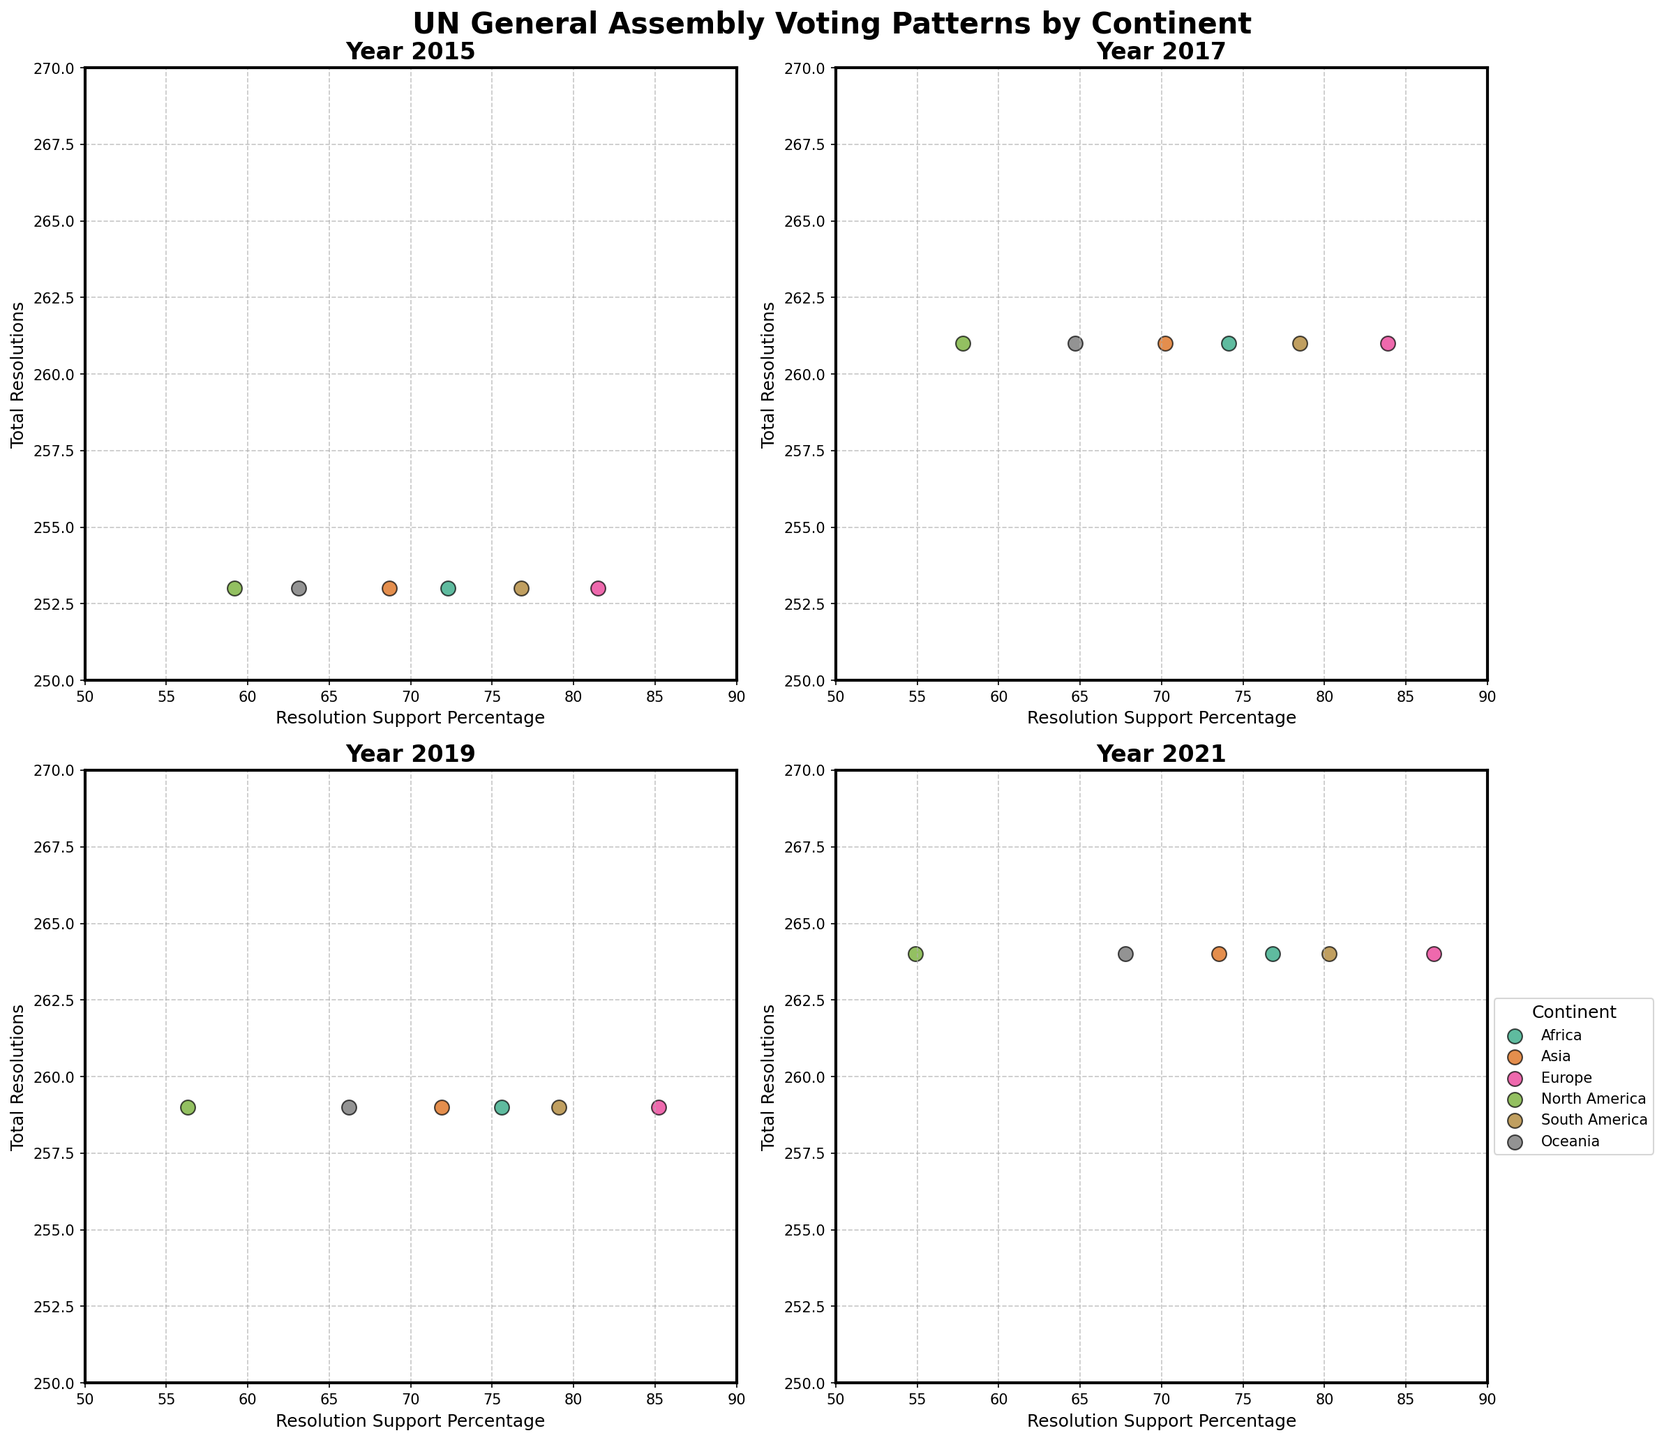What is the title of the figure? The title is displayed at the top center of the figure. It summarizes the overall topic of the figure.
Answer: UN General Assembly Voting Patterns by Continent Which continent had the highest resolution support percentage in 2021? Look at the subplot titled "Year 2021". Identify the highest y-value (resolution support percentage) and check which continent it corresponds to.
Answer: Europe Which continent supported the fewest number of resolutions in 2019? Look at the subplot titled "Year 2019". Identify the smallest x-value (total resolutions) and check which continent it corresponds to.
Answer: North America How does Oceania's resolution support percentage change from 2015 to 2021? Look at the resolution support percentages for Oceania in the subplots for 2015 and 2021. Subtract the 2015 value from the 2021 value (67.8% - 63.1%).
Answer: 4.7% Compare Asia and Africa in terms of resolution support percentage in 2017. Which has a higher value? Look at the subplot titled "Year 2017". Locate Asia and Africa's data points and compare their y-values (resolution support percentages).
Answer: Africa Which year shows the most similar resolution support percentages for Europe and South America? Compare Europe's and South America's y-values (resolution support percentages) across all subplots and find the year in which these values are closest.
Answer: 2019 Is the trend of Europe’s support percentage increasing or decreasing from 2015 to 2021? Observe the y-values (resolution support percentages) of Europe across all subplots from 2015 to 2021. Note if the values are increasing each year.
Answer: Increasing Which continent consistently has the lowest resolution support percentage from 2015 to 2021? For each year, identify the continent with the lowest y-value (resolution support percentage) in the subplots. Check for consistency across all years.
Answer: North America What is the average resolution support percentage for South America across all years? Look at the resolution support percentages for South America in each subplot and calculate the average (76.8 + 78.5 + 79.1 + 80.3) / 4.
Answer: 78.675% 